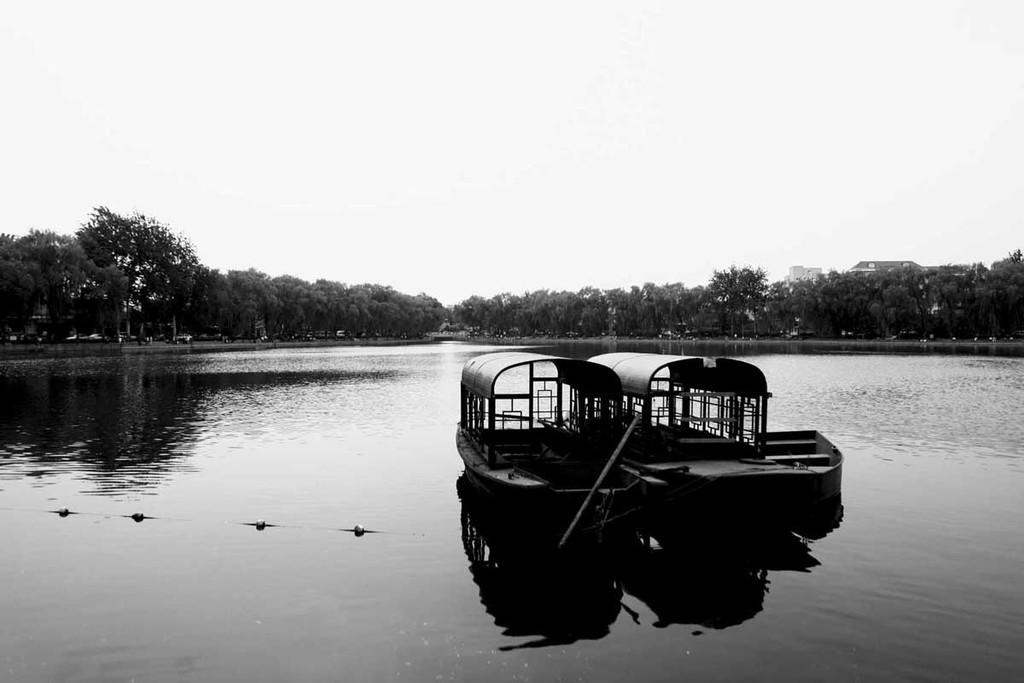What type of vehicles are in the image? There are boats in the image. Where are the boats located? The boats are on the water. What can be seen in the background of the image? There are trees and the sky in the background of the image. What is the color scheme of the image? The image is black and white in color. What type of education can be seen being provided in the image? There is no education being provided in the image; it features boats on the water with a black and white color scheme. What type of eggnog is being served in the image? There is no eggnog present in the image; it features boats on the water with a black and white color scheme. 